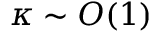Convert formula to latex. <formula><loc_0><loc_0><loc_500><loc_500>\kappa \sim O ( 1 )</formula> 